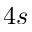Convert formula to latex. <formula><loc_0><loc_0><loc_500><loc_500>4 s</formula> 